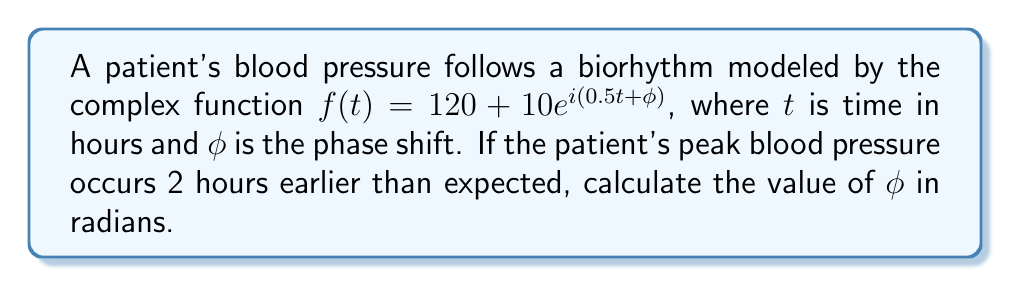Solve this math problem. To solve this problem, we'll follow these steps:

1) In the given function $f(t) = 120 + 10e^{i(0.5t + \phi)}$, the complex exponential $e^{i(0.5t + \phi)}$ represents the oscillating component of the biorhythm.

2) The angular frequency $\omega$ is 0.5 radians per hour, as seen in the exponent $0.5t$.

3) The period of this oscillation is:

   $$T = \frac{2\pi}{\omega} = \frac{2\pi}{0.5} = 4\pi \approx 12.57 \text{ hours}$$

4) If the peak occurs 2 hours earlier, this represents a phase shift of:

   $$\text{Phase shift} = -\frac{2 \text{ hours}}{12.57 \text{ hours}} \cdot 2\pi \text{ radians} \approx -1 \text{ radian}$$

5) The negative sign indicates that the peak occurs earlier.

6) Therefore, $\phi = -1 \text{ radian}$.

This phase shift in the complex exponential will cause the biorhythm to reach its peak 2 hours earlier than it would without the phase shift.
Answer: $\phi = -1 \text{ radian}$ 